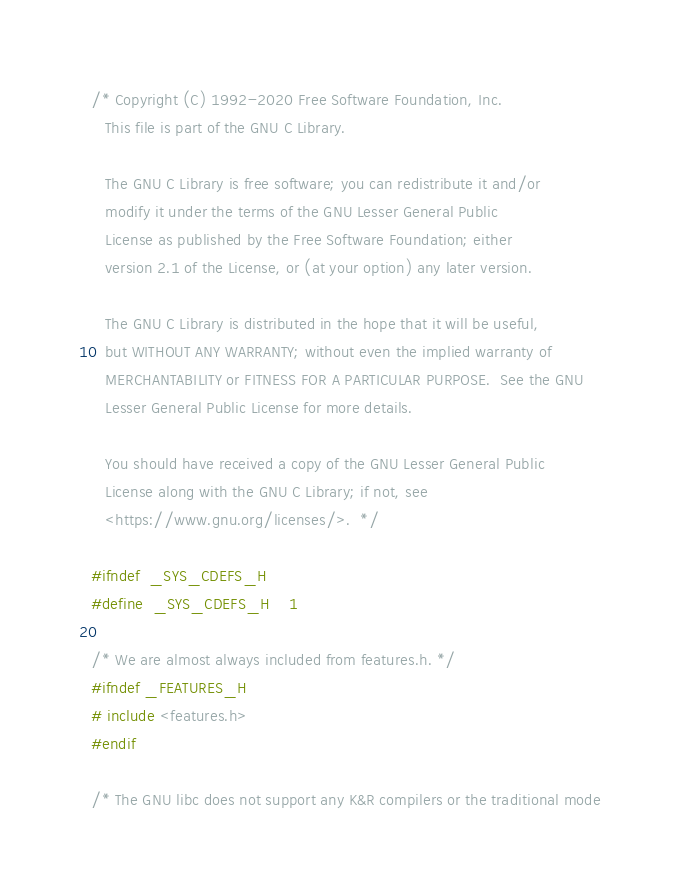<code> <loc_0><loc_0><loc_500><loc_500><_C_>/* Copyright (C) 1992-2020 Free Software Foundation, Inc.
   This file is part of the GNU C Library.

   The GNU C Library is free software; you can redistribute it and/or
   modify it under the terms of the GNU Lesser General Public
   License as published by the Free Software Foundation; either
   version 2.1 of the License, or (at your option) any later version.

   The GNU C Library is distributed in the hope that it will be useful,
   but WITHOUT ANY WARRANTY; without even the implied warranty of
   MERCHANTABILITY or FITNESS FOR A PARTICULAR PURPOSE.  See the GNU
   Lesser General Public License for more details.

   You should have received a copy of the GNU Lesser General Public
   License along with the GNU C Library; if not, see
   <https://www.gnu.org/licenses/>.  */

#ifndef	_SYS_CDEFS_H
#define	_SYS_CDEFS_H	1

/* We are almost always included from features.h. */
#ifndef _FEATURES_H
# include <features.h>
#endif

/* The GNU libc does not support any K&R compilers or the traditional mode</code> 